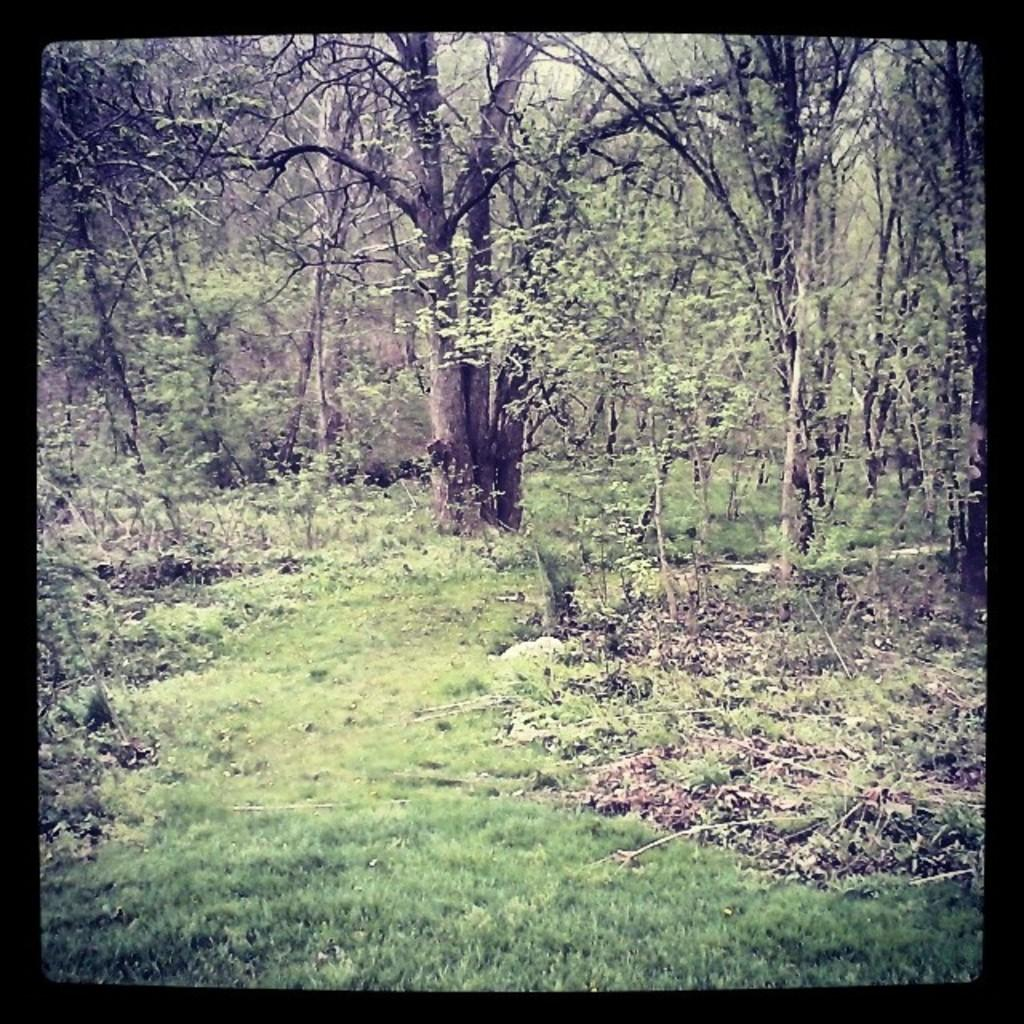What type of vegetation can be seen in the image? There are trees, plants, and grass visible in the image. Can you describe the ground in the image? The ground in the image is covered with grass. What type of veil can be seen hanging from the trees in the image? There is no veil present in the image; only trees, plants, and grass are visible. What type of taste can be experienced from the plants in the image? The image does not provide information about the taste of the plants, as it is a visual representation. 